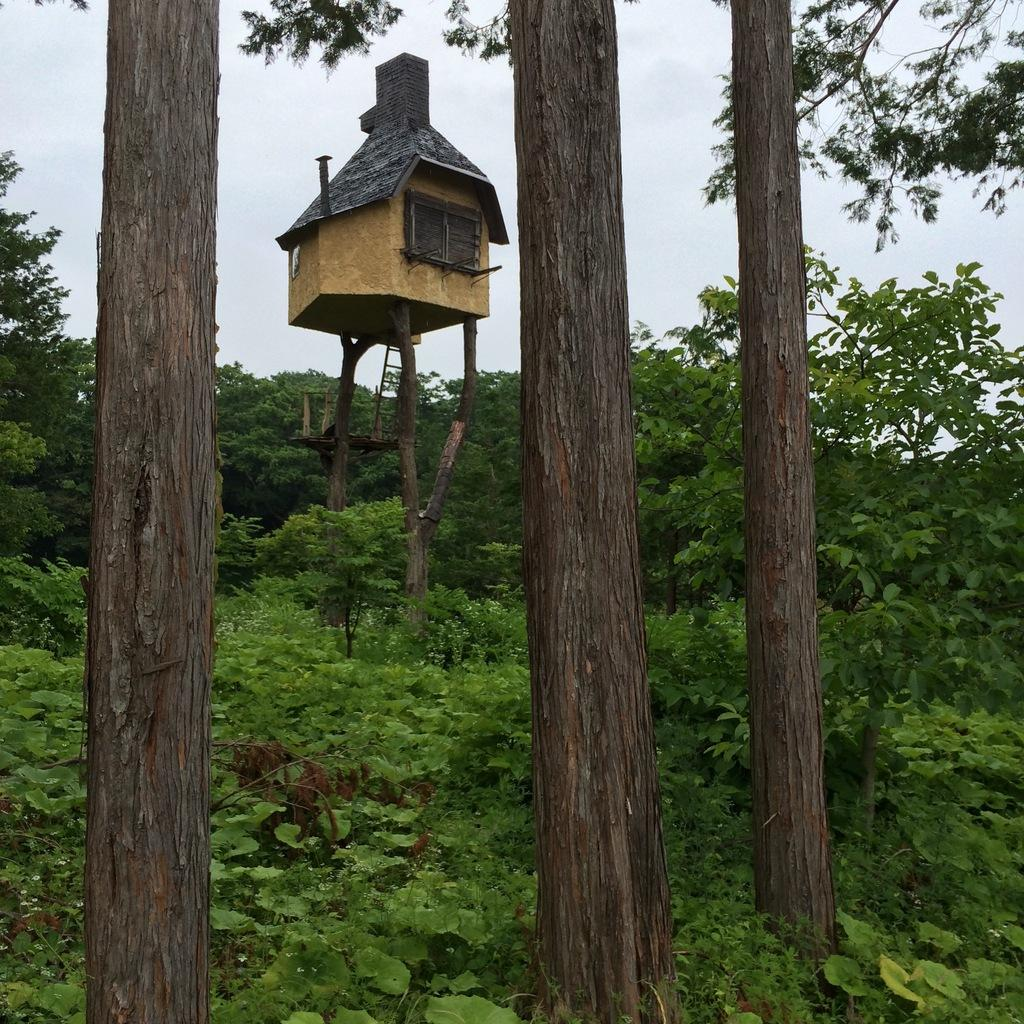What type of vegetation can be seen in the image? There are trees in the image. What structure is located at the center of the image? There is a tree house at the center of the image. What is visible in the background of the image? The sky is visible in the background of the image. Where is the jar of pickles located in the image? There is no jar of pickles present in the image. Can you see a zebra in the tree house? There is no zebra present in the image. 